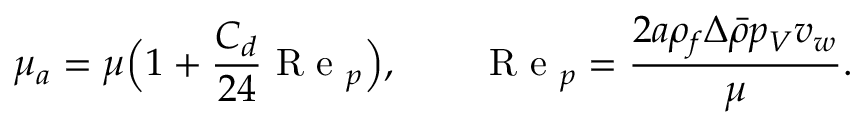Convert formula to latex. <formula><loc_0><loc_0><loc_500><loc_500>\mu _ { a } = \mu \left ( 1 + \frac { C _ { d } } { 2 4 } R e _ { p } \right ) , \quad R e _ { p } = \frac { 2 a \rho _ { f } \Delta \bar { \rho } p _ { V } v _ { w } } { \mu } .</formula> 